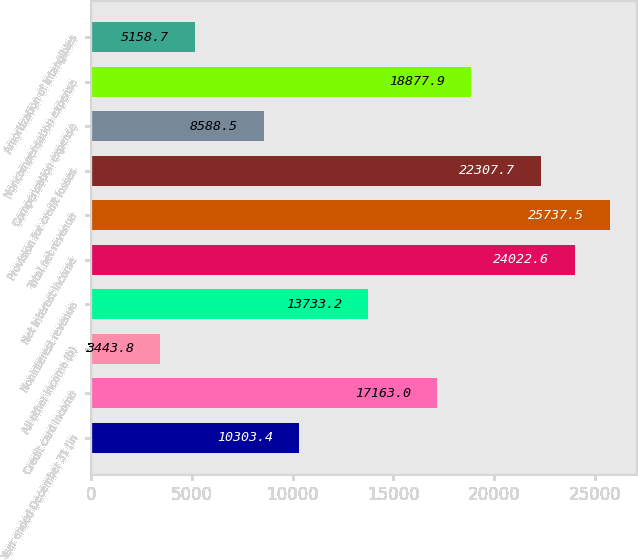Convert chart to OTSL. <chart><loc_0><loc_0><loc_500><loc_500><bar_chart><fcel>Year ended December 31 (in<fcel>Credit card income<fcel>All other income (b)<fcel>Noninterest revenue<fcel>Net interest income<fcel>Total net revenue<fcel>Provision for credit losses<fcel>Compensation expense<fcel>Noncompensation expense<fcel>Amortization of intangibles<nl><fcel>10303.4<fcel>17163<fcel>3443.8<fcel>13733.2<fcel>24022.6<fcel>25737.5<fcel>22307.7<fcel>8588.5<fcel>18877.9<fcel>5158.7<nl></chart> 